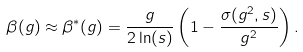Convert formula to latex. <formula><loc_0><loc_0><loc_500><loc_500>\beta ( g ) \approx \beta ^ { * } ( g ) = \frac { g } { 2 \ln ( s ) } \left ( 1 - \frac { \sigma ( g ^ { 2 } , s ) } { g ^ { 2 } } \right ) .</formula> 